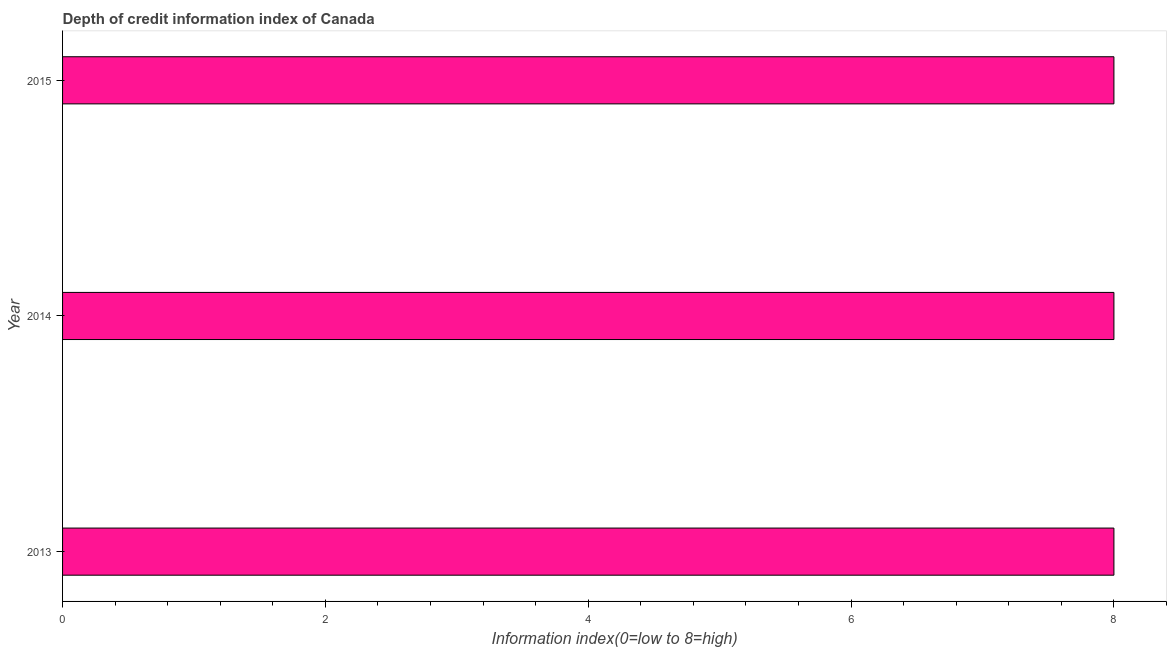Does the graph contain grids?
Provide a succinct answer. No. What is the title of the graph?
Keep it short and to the point. Depth of credit information index of Canada. What is the label or title of the X-axis?
Keep it short and to the point. Information index(0=low to 8=high). What is the label or title of the Y-axis?
Your answer should be very brief. Year. Across all years, what is the maximum depth of credit information index?
Keep it short and to the point. 8. Across all years, what is the minimum depth of credit information index?
Provide a succinct answer. 8. In which year was the depth of credit information index minimum?
Offer a terse response. 2013. What is the sum of the depth of credit information index?
Offer a terse response. 24. What is the average depth of credit information index per year?
Ensure brevity in your answer.  8. What is the median depth of credit information index?
Your answer should be compact. 8. In how many years, is the depth of credit information index greater than 7.2 ?
Keep it short and to the point. 3. Is the sum of the depth of credit information index in 2013 and 2015 greater than the maximum depth of credit information index across all years?
Offer a terse response. Yes. How many bars are there?
Give a very brief answer. 3. How many years are there in the graph?
Provide a short and direct response. 3. Are the values on the major ticks of X-axis written in scientific E-notation?
Provide a succinct answer. No. What is the Information index(0=low to 8=high) of 2013?
Your answer should be very brief. 8. What is the Information index(0=low to 8=high) in 2015?
Give a very brief answer. 8. What is the ratio of the Information index(0=low to 8=high) in 2013 to that in 2015?
Your answer should be very brief. 1. 